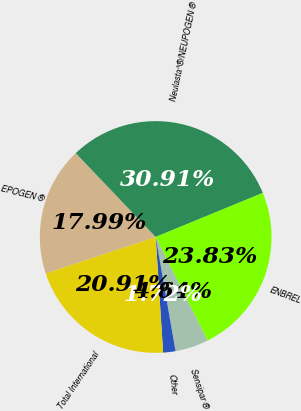Convert chart to OTSL. <chart><loc_0><loc_0><loc_500><loc_500><pie_chart><fcel>EPOGEN ®<fcel>Neulasta^®/NEUPOGEN ®<fcel>ENBREL<fcel>Sensipar ®<fcel>Other<fcel>Total International<nl><fcel>17.99%<fcel>30.91%<fcel>23.83%<fcel>4.64%<fcel>1.72%<fcel>20.91%<nl></chart> 